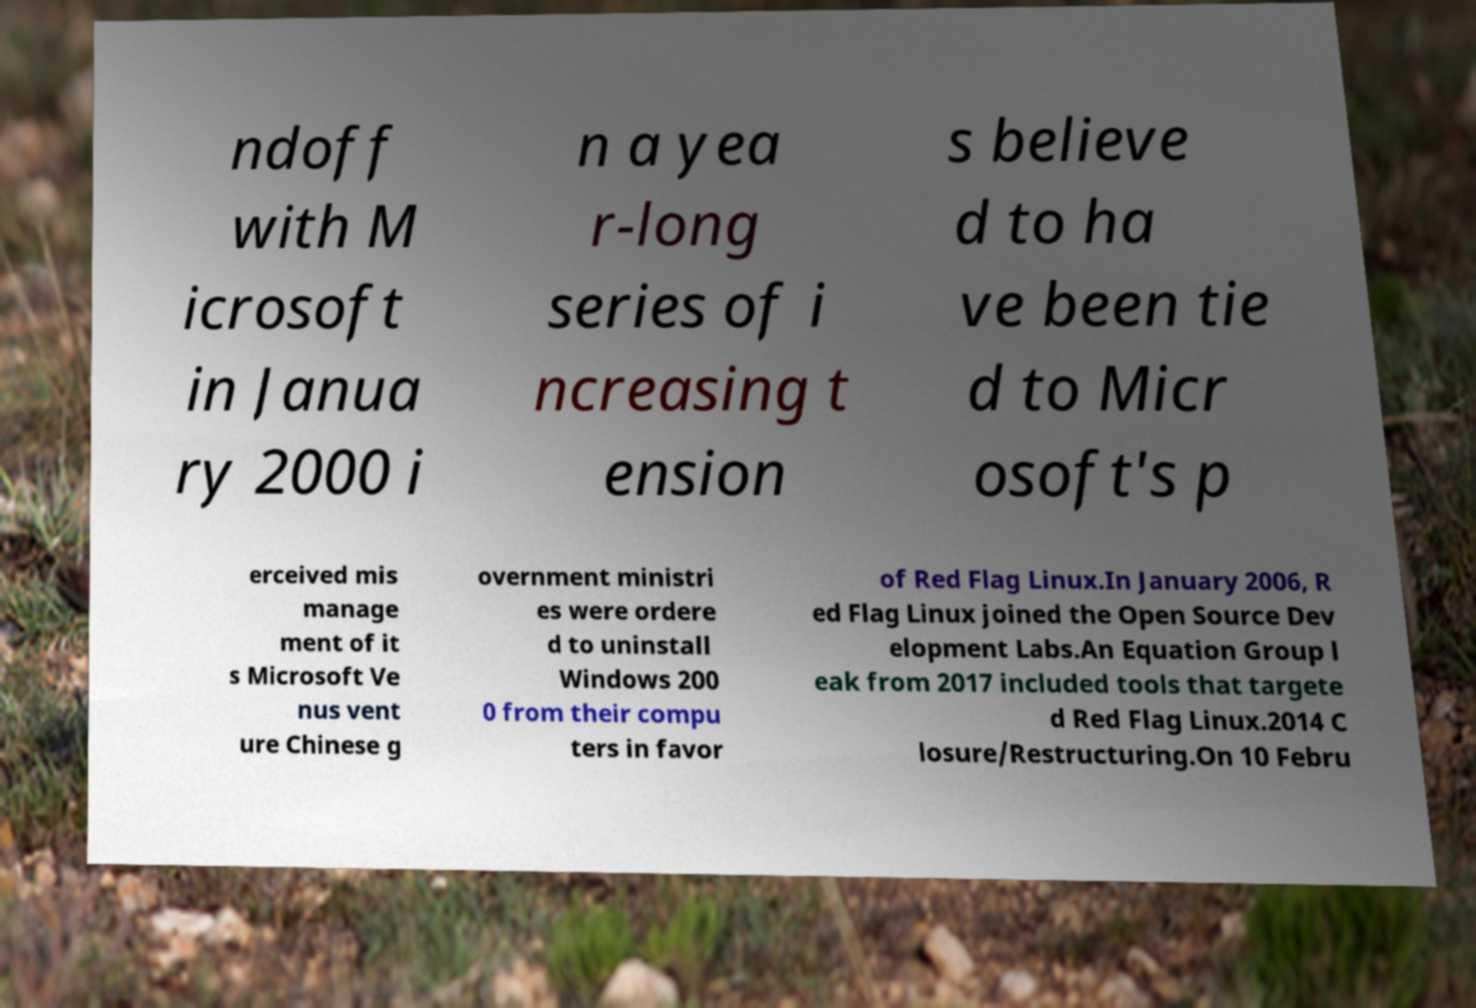I need the written content from this picture converted into text. Can you do that? ndoff with M icrosoft in Janua ry 2000 i n a yea r-long series of i ncreasing t ension s believe d to ha ve been tie d to Micr osoft's p erceived mis manage ment of it s Microsoft Ve nus vent ure Chinese g overnment ministri es were ordere d to uninstall Windows 200 0 from their compu ters in favor of Red Flag Linux.In January 2006, R ed Flag Linux joined the Open Source Dev elopment Labs.An Equation Group l eak from 2017 included tools that targete d Red Flag Linux.2014 C losure/Restructuring.On 10 Febru 